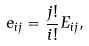Convert formula to latex. <formula><loc_0><loc_0><loc_500><loc_500>e _ { i j } = \frac { j ! } { i ! } E _ { i j } ,</formula> 